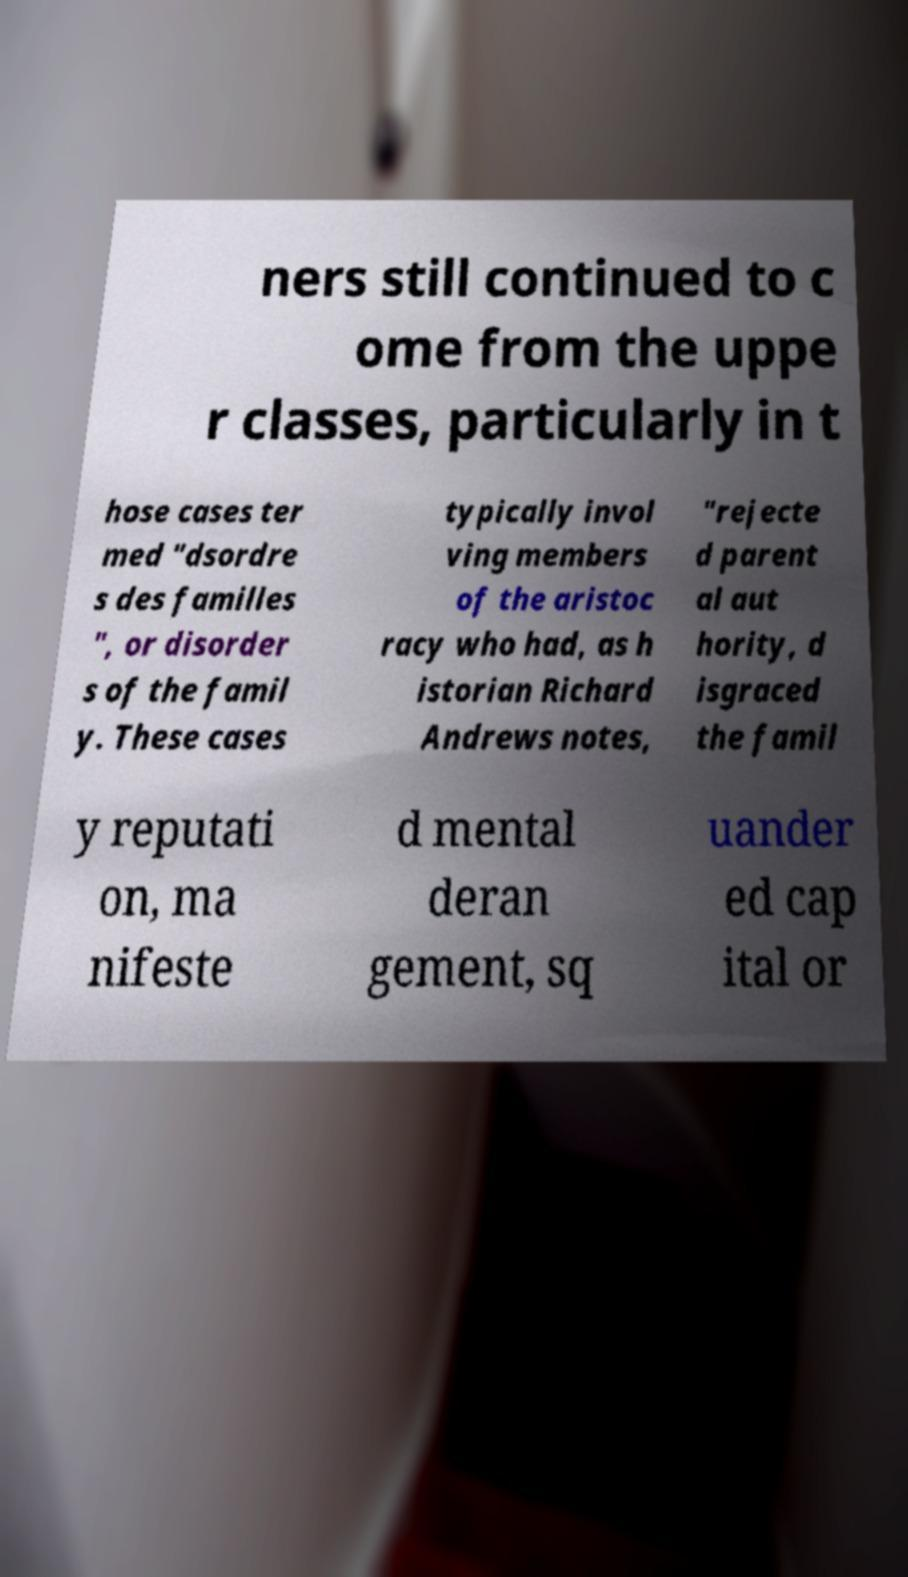I need the written content from this picture converted into text. Can you do that? ners still continued to c ome from the uppe r classes, particularly in t hose cases ter med "dsordre s des familles ", or disorder s of the famil y. These cases typically invol ving members of the aristoc racy who had, as h istorian Richard Andrews notes, "rejecte d parent al aut hority, d isgraced the famil y reputati on, ma nifeste d mental deran gement, sq uander ed cap ital or 